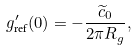Convert formula to latex. <formula><loc_0><loc_0><loc_500><loc_500>g _ { \text {ref} } ^ { \prime } ( 0 ) = - \frac { \widetilde { c } _ { 0 } } { 2 \pi R _ { g } } ,</formula> 